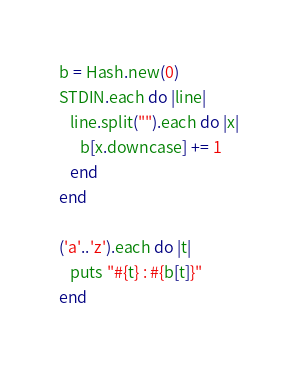Convert code to text. <code><loc_0><loc_0><loc_500><loc_500><_Ruby_>b = Hash.new(0)
STDIN.each do |line|
   line.split("").each do |x|
      b[x.downcase] += 1
   end
end

('a'..'z').each do |t|
   puts "#{t} : #{b[t]}"
end</code> 